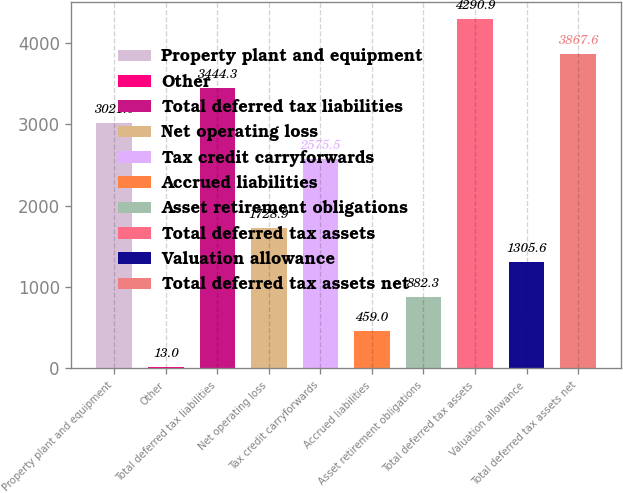<chart> <loc_0><loc_0><loc_500><loc_500><bar_chart><fcel>Property plant and equipment<fcel>Other<fcel>Total deferred tax liabilities<fcel>Net operating loss<fcel>Tax credit carryforwards<fcel>Accrued liabilities<fcel>Asset retirement obligations<fcel>Total deferred tax assets<fcel>Valuation allowance<fcel>Total deferred tax assets net<nl><fcel>3021<fcel>13<fcel>3444.3<fcel>1728.9<fcel>2575.5<fcel>459<fcel>882.3<fcel>4290.9<fcel>1305.6<fcel>3867.6<nl></chart> 